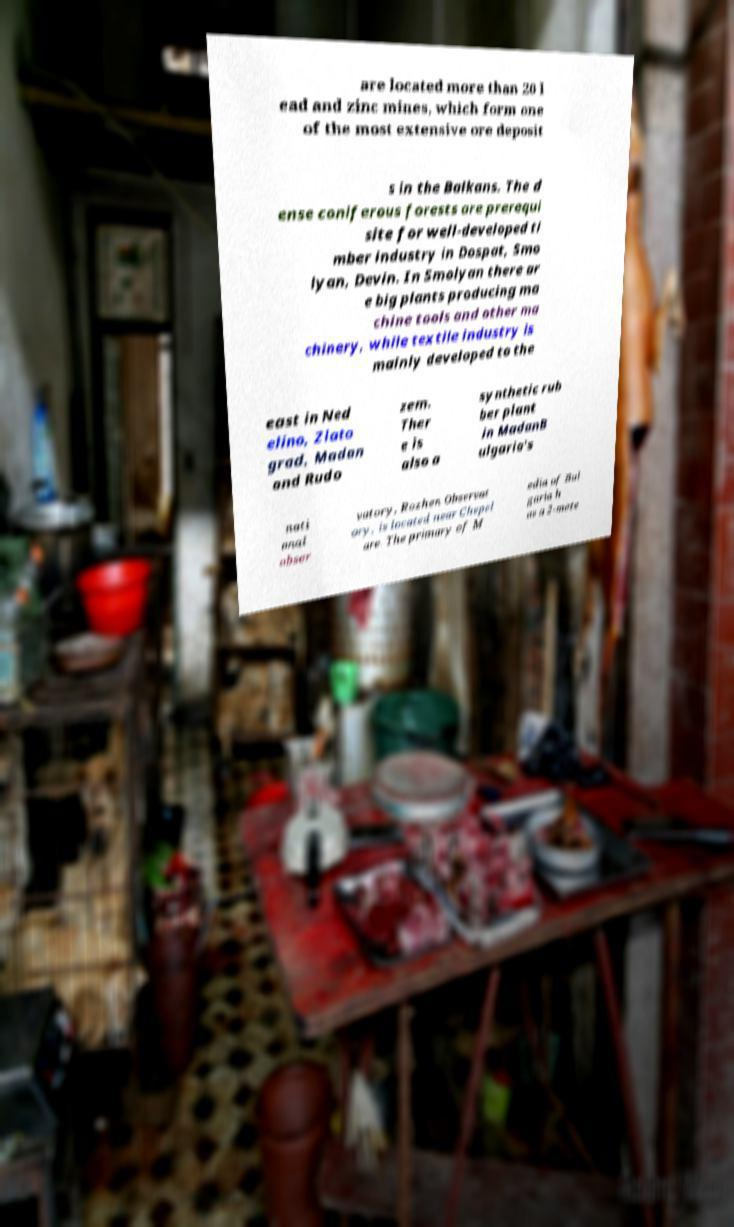There's text embedded in this image that I need extracted. Can you transcribe it verbatim? are located more than 20 l ead and zinc mines, which form one of the most extensive ore deposit s in the Balkans. The d ense coniferous forests are prerequi site for well-developed ti mber industry in Dospat, Smo lyan, Devin. In Smolyan there ar e big plants producing ma chine tools and other ma chinery, while textile industry is mainly developed to the east in Ned elino, Zlato grad, Madan and Rudo zem. Ther e is also a synthetic rub ber plant in MadanB ulgaria's nati onal obser vatory, Rozhen Observat ory, is located near Chepel are. The primary of M edia of Bul garia h as a 2-mete 